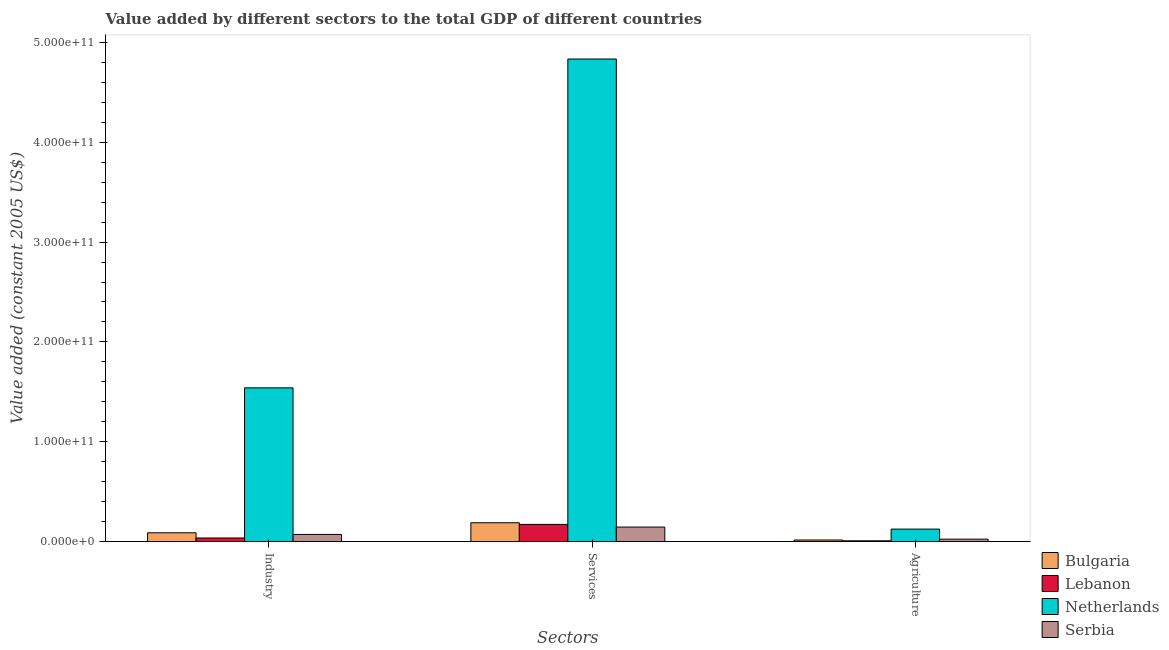How many groups of bars are there?
Your answer should be very brief. 3. Are the number of bars on each tick of the X-axis equal?
Offer a terse response. Yes. How many bars are there on the 2nd tick from the left?
Your answer should be compact. 4. What is the label of the 3rd group of bars from the left?
Provide a succinct answer. Agriculture. What is the value added by agricultural sector in Serbia?
Provide a succinct answer. 2.41e+09. Across all countries, what is the maximum value added by industrial sector?
Provide a succinct answer. 1.54e+11. Across all countries, what is the minimum value added by industrial sector?
Offer a very short reply. 3.59e+09. In which country was the value added by agricultural sector minimum?
Your answer should be compact. Lebanon. What is the total value added by industrial sector in the graph?
Offer a terse response. 1.74e+11. What is the difference between the value added by services in Lebanon and that in Netherlands?
Provide a succinct answer. -4.66e+11. What is the difference between the value added by agricultural sector in Lebanon and the value added by industrial sector in Bulgaria?
Ensure brevity in your answer.  -8.03e+09. What is the average value added by agricultural sector per country?
Provide a short and direct response. 4.30e+09. What is the difference between the value added by services and value added by industrial sector in Netherlands?
Offer a terse response. 3.29e+11. What is the ratio of the value added by industrial sector in Lebanon to that in Netherlands?
Ensure brevity in your answer.  0.02. What is the difference between the highest and the second highest value added by industrial sector?
Provide a succinct answer. 1.45e+11. What is the difference between the highest and the lowest value added by industrial sector?
Keep it short and to the point. 1.50e+11. In how many countries, is the value added by agricultural sector greater than the average value added by agricultural sector taken over all countries?
Offer a very short reply. 1. What does the 3rd bar from the left in Industry represents?
Your answer should be very brief. Netherlands. What does the 1st bar from the right in Industry represents?
Keep it short and to the point. Serbia. How many bars are there?
Provide a short and direct response. 12. Are all the bars in the graph horizontal?
Offer a terse response. No. How many countries are there in the graph?
Provide a succinct answer. 4. What is the difference between two consecutive major ticks on the Y-axis?
Give a very brief answer. 1.00e+11. Are the values on the major ticks of Y-axis written in scientific E-notation?
Your answer should be compact. Yes. Does the graph contain any zero values?
Make the answer very short. No. How many legend labels are there?
Your answer should be very brief. 4. How are the legend labels stacked?
Make the answer very short. Vertical. What is the title of the graph?
Your answer should be very brief. Value added by different sectors to the total GDP of different countries. Does "Ireland" appear as one of the legend labels in the graph?
Your response must be concise. No. What is the label or title of the X-axis?
Keep it short and to the point. Sectors. What is the label or title of the Y-axis?
Offer a very short reply. Value added (constant 2005 US$). What is the Value added (constant 2005 US$) of Bulgaria in Industry?
Provide a short and direct response. 8.79e+09. What is the Value added (constant 2005 US$) of Lebanon in Industry?
Provide a succinct answer. 3.59e+09. What is the Value added (constant 2005 US$) in Netherlands in Industry?
Offer a very short reply. 1.54e+11. What is the Value added (constant 2005 US$) of Serbia in Industry?
Give a very brief answer. 7.14e+09. What is the Value added (constant 2005 US$) of Bulgaria in Services?
Offer a very short reply. 1.88e+1. What is the Value added (constant 2005 US$) of Lebanon in Services?
Give a very brief answer. 1.72e+1. What is the Value added (constant 2005 US$) in Netherlands in Services?
Your response must be concise. 4.83e+11. What is the Value added (constant 2005 US$) in Serbia in Services?
Make the answer very short. 1.45e+1. What is the Value added (constant 2005 US$) in Bulgaria in Agriculture?
Your answer should be very brief. 1.57e+09. What is the Value added (constant 2005 US$) in Lebanon in Agriculture?
Provide a short and direct response. 7.62e+08. What is the Value added (constant 2005 US$) of Netherlands in Agriculture?
Your response must be concise. 1.25e+1. What is the Value added (constant 2005 US$) of Serbia in Agriculture?
Your answer should be compact. 2.41e+09. Across all Sectors, what is the maximum Value added (constant 2005 US$) in Bulgaria?
Keep it short and to the point. 1.88e+1. Across all Sectors, what is the maximum Value added (constant 2005 US$) of Lebanon?
Your response must be concise. 1.72e+1. Across all Sectors, what is the maximum Value added (constant 2005 US$) of Netherlands?
Provide a short and direct response. 4.83e+11. Across all Sectors, what is the maximum Value added (constant 2005 US$) in Serbia?
Ensure brevity in your answer.  1.45e+1. Across all Sectors, what is the minimum Value added (constant 2005 US$) in Bulgaria?
Your answer should be very brief. 1.57e+09. Across all Sectors, what is the minimum Value added (constant 2005 US$) in Lebanon?
Make the answer very short. 7.62e+08. Across all Sectors, what is the minimum Value added (constant 2005 US$) in Netherlands?
Keep it short and to the point. 1.25e+1. Across all Sectors, what is the minimum Value added (constant 2005 US$) of Serbia?
Provide a succinct answer. 2.41e+09. What is the total Value added (constant 2005 US$) in Bulgaria in the graph?
Your response must be concise. 2.92e+1. What is the total Value added (constant 2005 US$) in Lebanon in the graph?
Make the answer very short. 2.16e+1. What is the total Value added (constant 2005 US$) of Netherlands in the graph?
Offer a very short reply. 6.50e+11. What is the total Value added (constant 2005 US$) in Serbia in the graph?
Your answer should be compact. 2.41e+1. What is the difference between the Value added (constant 2005 US$) in Bulgaria in Industry and that in Services?
Make the answer very short. -1.01e+1. What is the difference between the Value added (constant 2005 US$) in Lebanon in Industry and that in Services?
Make the answer very short. -1.36e+1. What is the difference between the Value added (constant 2005 US$) of Netherlands in Industry and that in Services?
Provide a short and direct response. -3.29e+11. What is the difference between the Value added (constant 2005 US$) in Serbia in Industry and that in Services?
Make the answer very short. -7.38e+09. What is the difference between the Value added (constant 2005 US$) of Bulgaria in Industry and that in Agriculture?
Offer a very short reply. 7.22e+09. What is the difference between the Value added (constant 2005 US$) of Lebanon in Industry and that in Agriculture?
Ensure brevity in your answer.  2.83e+09. What is the difference between the Value added (constant 2005 US$) in Netherlands in Industry and that in Agriculture?
Your answer should be compact. 1.42e+11. What is the difference between the Value added (constant 2005 US$) of Serbia in Industry and that in Agriculture?
Offer a very short reply. 4.73e+09. What is the difference between the Value added (constant 2005 US$) in Bulgaria in Services and that in Agriculture?
Give a very brief answer. 1.73e+1. What is the difference between the Value added (constant 2005 US$) in Lebanon in Services and that in Agriculture?
Offer a terse response. 1.64e+1. What is the difference between the Value added (constant 2005 US$) of Netherlands in Services and that in Agriculture?
Provide a succinct answer. 4.71e+11. What is the difference between the Value added (constant 2005 US$) of Serbia in Services and that in Agriculture?
Make the answer very short. 1.21e+1. What is the difference between the Value added (constant 2005 US$) of Bulgaria in Industry and the Value added (constant 2005 US$) of Lebanon in Services?
Offer a very short reply. -8.41e+09. What is the difference between the Value added (constant 2005 US$) of Bulgaria in Industry and the Value added (constant 2005 US$) of Netherlands in Services?
Offer a terse response. -4.75e+11. What is the difference between the Value added (constant 2005 US$) in Bulgaria in Industry and the Value added (constant 2005 US$) in Serbia in Services?
Your answer should be compact. -5.74e+09. What is the difference between the Value added (constant 2005 US$) of Lebanon in Industry and the Value added (constant 2005 US$) of Netherlands in Services?
Offer a very short reply. -4.80e+11. What is the difference between the Value added (constant 2005 US$) of Lebanon in Industry and the Value added (constant 2005 US$) of Serbia in Services?
Your answer should be very brief. -1.09e+1. What is the difference between the Value added (constant 2005 US$) in Netherlands in Industry and the Value added (constant 2005 US$) in Serbia in Services?
Ensure brevity in your answer.  1.39e+11. What is the difference between the Value added (constant 2005 US$) of Bulgaria in Industry and the Value added (constant 2005 US$) of Lebanon in Agriculture?
Keep it short and to the point. 8.03e+09. What is the difference between the Value added (constant 2005 US$) of Bulgaria in Industry and the Value added (constant 2005 US$) of Netherlands in Agriculture?
Offer a very short reply. -3.69e+09. What is the difference between the Value added (constant 2005 US$) in Bulgaria in Industry and the Value added (constant 2005 US$) in Serbia in Agriculture?
Your answer should be compact. 6.38e+09. What is the difference between the Value added (constant 2005 US$) in Lebanon in Industry and the Value added (constant 2005 US$) in Netherlands in Agriculture?
Make the answer very short. -8.88e+09. What is the difference between the Value added (constant 2005 US$) of Lebanon in Industry and the Value added (constant 2005 US$) of Serbia in Agriculture?
Your response must be concise. 1.18e+09. What is the difference between the Value added (constant 2005 US$) of Netherlands in Industry and the Value added (constant 2005 US$) of Serbia in Agriculture?
Offer a terse response. 1.52e+11. What is the difference between the Value added (constant 2005 US$) in Bulgaria in Services and the Value added (constant 2005 US$) in Lebanon in Agriculture?
Your answer should be very brief. 1.81e+1. What is the difference between the Value added (constant 2005 US$) in Bulgaria in Services and the Value added (constant 2005 US$) in Netherlands in Agriculture?
Make the answer very short. 6.37e+09. What is the difference between the Value added (constant 2005 US$) of Bulgaria in Services and the Value added (constant 2005 US$) of Serbia in Agriculture?
Your answer should be very brief. 1.64e+1. What is the difference between the Value added (constant 2005 US$) of Lebanon in Services and the Value added (constant 2005 US$) of Netherlands in Agriculture?
Provide a short and direct response. 4.72e+09. What is the difference between the Value added (constant 2005 US$) of Lebanon in Services and the Value added (constant 2005 US$) of Serbia in Agriculture?
Give a very brief answer. 1.48e+1. What is the difference between the Value added (constant 2005 US$) in Netherlands in Services and the Value added (constant 2005 US$) in Serbia in Agriculture?
Provide a short and direct response. 4.81e+11. What is the average Value added (constant 2005 US$) of Bulgaria per Sectors?
Offer a terse response. 9.73e+09. What is the average Value added (constant 2005 US$) in Lebanon per Sectors?
Provide a succinct answer. 7.18e+09. What is the average Value added (constant 2005 US$) of Netherlands per Sectors?
Your answer should be very brief. 2.17e+11. What is the average Value added (constant 2005 US$) in Serbia per Sectors?
Give a very brief answer. 8.03e+09. What is the difference between the Value added (constant 2005 US$) of Bulgaria and Value added (constant 2005 US$) of Lebanon in Industry?
Your answer should be compact. 5.20e+09. What is the difference between the Value added (constant 2005 US$) in Bulgaria and Value added (constant 2005 US$) in Netherlands in Industry?
Your answer should be compact. -1.45e+11. What is the difference between the Value added (constant 2005 US$) in Bulgaria and Value added (constant 2005 US$) in Serbia in Industry?
Give a very brief answer. 1.65e+09. What is the difference between the Value added (constant 2005 US$) of Lebanon and Value added (constant 2005 US$) of Netherlands in Industry?
Keep it short and to the point. -1.50e+11. What is the difference between the Value added (constant 2005 US$) of Lebanon and Value added (constant 2005 US$) of Serbia in Industry?
Make the answer very short. -3.55e+09. What is the difference between the Value added (constant 2005 US$) of Netherlands and Value added (constant 2005 US$) of Serbia in Industry?
Ensure brevity in your answer.  1.47e+11. What is the difference between the Value added (constant 2005 US$) in Bulgaria and Value added (constant 2005 US$) in Lebanon in Services?
Keep it short and to the point. 1.65e+09. What is the difference between the Value added (constant 2005 US$) in Bulgaria and Value added (constant 2005 US$) in Netherlands in Services?
Your answer should be compact. -4.65e+11. What is the difference between the Value added (constant 2005 US$) of Bulgaria and Value added (constant 2005 US$) of Serbia in Services?
Make the answer very short. 4.31e+09. What is the difference between the Value added (constant 2005 US$) in Lebanon and Value added (constant 2005 US$) in Netherlands in Services?
Make the answer very short. -4.66e+11. What is the difference between the Value added (constant 2005 US$) in Lebanon and Value added (constant 2005 US$) in Serbia in Services?
Provide a succinct answer. 2.67e+09. What is the difference between the Value added (constant 2005 US$) of Netherlands and Value added (constant 2005 US$) of Serbia in Services?
Make the answer very short. 4.69e+11. What is the difference between the Value added (constant 2005 US$) of Bulgaria and Value added (constant 2005 US$) of Lebanon in Agriculture?
Keep it short and to the point. 8.07e+08. What is the difference between the Value added (constant 2005 US$) of Bulgaria and Value added (constant 2005 US$) of Netherlands in Agriculture?
Provide a short and direct response. -1.09e+1. What is the difference between the Value added (constant 2005 US$) of Bulgaria and Value added (constant 2005 US$) of Serbia in Agriculture?
Make the answer very short. -8.42e+08. What is the difference between the Value added (constant 2005 US$) of Lebanon and Value added (constant 2005 US$) of Netherlands in Agriculture?
Your response must be concise. -1.17e+1. What is the difference between the Value added (constant 2005 US$) in Lebanon and Value added (constant 2005 US$) in Serbia in Agriculture?
Ensure brevity in your answer.  -1.65e+09. What is the difference between the Value added (constant 2005 US$) in Netherlands and Value added (constant 2005 US$) in Serbia in Agriculture?
Provide a short and direct response. 1.01e+1. What is the ratio of the Value added (constant 2005 US$) of Bulgaria in Industry to that in Services?
Your answer should be compact. 0.47. What is the ratio of the Value added (constant 2005 US$) of Lebanon in Industry to that in Services?
Make the answer very short. 0.21. What is the ratio of the Value added (constant 2005 US$) in Netherlands in Industry to that in Services?
Your response must be concise. 0.32. What is the ratio of the Value added (constant 2005 US$) in Serbia in Industry to that in Services?
Provide a succinct answer. 0.49. What is the ratio of the Value added (constant 2005 US$) in Bulgaria in Industry to that in Agriculture?
Offer a very short reply. 5.6. What is the ratio of the Value added (constant 2005 US$) in Lebanon in Industry to that in Agriculture?
Offer a very short reply. 4.72. What is the ratio of the Value added (constant 2005 US$) of Netherlands in Industry to that in Agriculture?
Your response must be concise. 12.34. What is the ratio of the Value added (constant 2005 US$) of Serbia in Industry to that in Agriculture?
Provide a short and direct response. 2.96. What is the ratio of the Value added (constant 2005 US$) in Bulgaria in Services to that in Agriculture?
Your answer should be very brief. 12.01. What is the ratio of the Value added (constant 2005 US$) in Lebanon in Services to that in Agriculture?
Your answer should be compact. 22.56. What is the ratio of the Value added (constant 2005 US$) in Netherlands in Services to that in Agriculture?
Your answer should be very brief. 38.75. What is the ratio of the Value added (constant 2005 US$) in Serbia in Services to that in Agriculture?
Provide a short and direct response. 6.02. What is the difference between the highest and the second highest Value added (constant 2005 US$) of Bulgaria?
Offer a terse response. 1.01e+1. What is the difference between the highest and the second highest Value added (constant 2005 US$) in Lebanon?
Offer a terse response. 1.36e+1. What is the difference between the highest and the second highest Value added (constant 2005 US$) in Netherlands?
Give a very brief answer. 3.29e+11. What is the difference between the highest and the second highest Value added (constant 2005 US$) of Serbia?
Your answer should be compact. 7.38e+09. What is the difference between the highest and the lowest Value added (constant 2005 US$) of Bulgaria?
Give a very brief answer. 1.73e+1. What is the difference between the highest and the lowest Value added (constant 2005 US$) of Lebanon?
Your response must be concise. 1.64e+1. What is the difference between the highest and the lowest Value added (constant 2005 US$) of Netherlands?
Your response must be concise. 4.71e+11. What is the difference between the highest and the lowest Value added (constant 2005 US$) of Serbia?
Offer a terse response. 1.21e+1. 